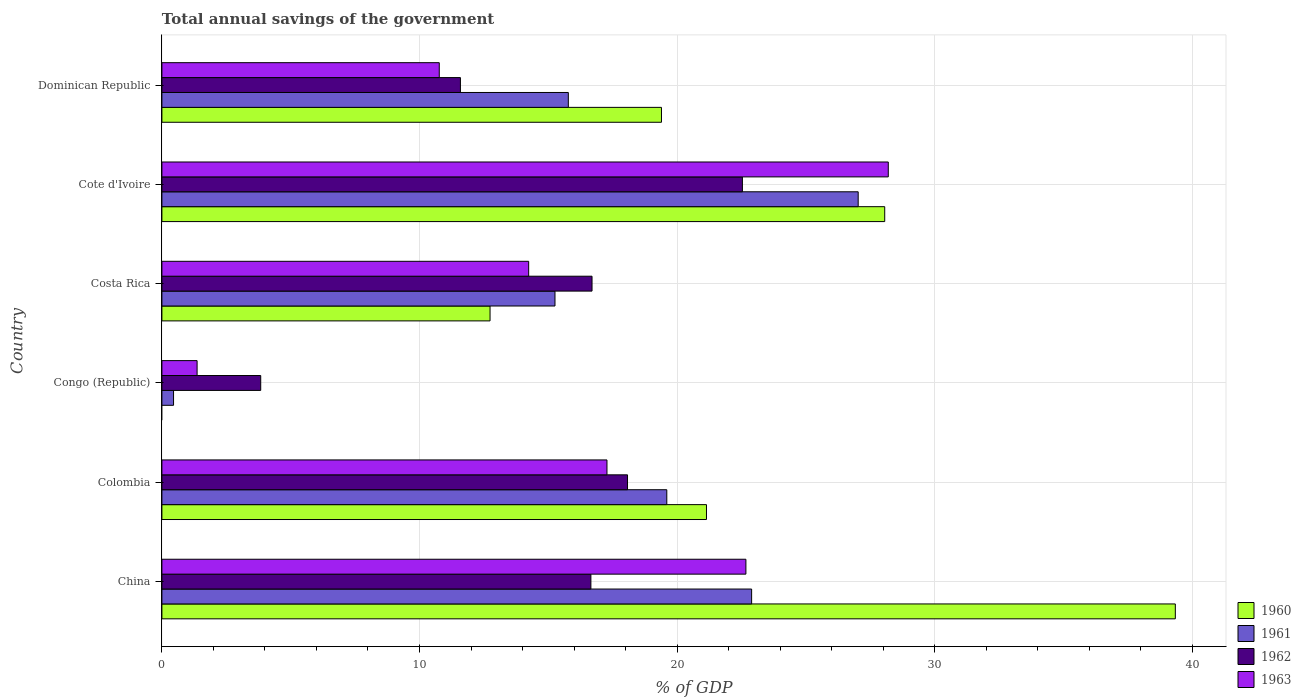How many groups of bars are there?
Offer a very short reply. 6. Are the number of bars per tick equal to the number of legend labels?
Your answer should be very brief. No. Are the number of bars on each tick of the Y-axis equal?
Your answer should be compact. No. What is the total annual savings of the government in 1961 in Congo (Republic)?
Provide a short and direct response. 0.45. Across all countries, what is the maximum total annual savings of the government in 1962?
Make the answer very short. 22.54. Across all countries, what is the minimum total annual savings of the government in 1963?
Your answer should be very brief. 1.37. In which country was the total annual savings of the government in 1962 maximum?
Keep it short and to the point. Cote d'Ivoire. What is the total total annual savings of the government in 1963 in the graph?
Your response must be concise. 94.52. What is the difference between the total annual savings of the government in 1963 in China and that in Cote d'Ivoire?
Offer a very short reply. -5.53. What is the difference between the total annual savings of the government in 1963 in Costa Rica and the total annual savings of the government in 1962 in Cote d'Ivoire?
Your answer should be very brief. -8.3. What is the average total annual savings of the government in 1963 per country?
Provide a short and direct response. 15.75. What is the difference between the total annual savings of the government in 1963 and total annual savings of the government in 1961 in China?
Keep it short and to the point. -0.22. In how many countries, is the total annual savings of the government in 1962 greater than 32 %?
Your response must be concise. 0. What is the ratio of the total annual savings of the government in 1963 in Congo (Republic) to that in Cote d'Ivoire?
Keep it short and to the point. 0.05. Is the total annual savings of the government in 1963 in China less than that in Dominican Republic?
Provide a succinct answer. No. What is the difference between the highest and the second highest total annual savings of the government in 1962?
Your answer should be compact. 4.46. What is the difference between the highest and the lowest total annual savings of the government in 1961?
Keep it short and to the point. 26.58. Are all the bars in the graph horizontal?
Keep it short and to the point. Yes. Does the graph contain any zero values?
Provide a short and direct response. Yes. Does the graph contain grids?
Your response must be concise. Yes. How are the legend labels stacked?
Provide a short and direct response. Vertical. What is the title of the graph?
Provide a succinct answer. Total annual savings of the government. Does "1969" appear as one of the legend labels in the graph?
Keep it short and to the point. No. What is the label or title of the X-axis?
Ensure brevity in your answer.  % of GDP. What is the label or title of the Y-axis?
Offer a terse response. Country. What is the % of GDP in 1960 in China?
Provide a short and direct response. 39.34. What is the % of GDP in 1961 in China?
Offer a very short reply. 22.89. What is the % of GDP in 1962 in China?
Keep it short and to the point. 16.65. What is the % of GDP of 1963 in China?
Provide a succinct answer. 22.67. What is the % of GDP of 1960 in Colombia?
Make the answer very short. 21.14. What is the % of GDP in 1961 in Colombia?
Keep it short and to the point. 19.6. What is the % of GDP of 1962 in Colombia?
Give a very brief answer. 18.08. What is the % of GDP in 1963 in Colombia?
Your response must be concise. 17.28. What is the % of GDP of 1960 in Congo (Republic)?
Your response must be concise. 0. What is the % of GDP of 1961 in Congo (Republic)?
Keep it short and to the point. 0.45. What is the % of GDP in 1962 in Congo (Republic)?
Your answer should be very brief. 3.84. What is the % of GDP in 1963 in Congo (Republic)?
Your response must be concise. 1.37. What is the % of GDP of 1960 in Costa Rica?
Offer a very short reply. 12.74. What is the % of GDP of 1961 in Costa Rica?
Your response must be concise. 15.26. What is the % of GDP in 1962 in Costa Rica?
Ensure brevity in your answer.  16.7. What is the % of GDP of 1963 in Costa Rica?
Your response must be concise. 14.24. What is the % of GDP in 1960 in Cote d'Ivoire?
Your answer should be compact. 28.06. What is the % of GDP in 1961 in Cote d'Ivoire?
Your answer should be very brief. 27.03. What is the % of GDP in 1962 in Cote d'Ivoire?
Your response must be concise. 22.54. What is the % of GDP of 1963 in Cote d'Ivoire?
Ensure brevity in your answer.  28.2. What is the % of GDP in 1960 in Dominican Republic?
Your response must be concise. 19.39. What is the % of GDP in 1961 in Dominican Republic?
Give a very brief answer. 15.78. What is the % of GDP in 1962 in Dominican Republic?
Provide a succinct answer. 11.59. What is the % of GDP of 1963 in Dominican Republic?
Provide a succinct answer. 10.77. Across all countries, what is the maximum % of GDP of 1960?
Your answer should be compact. 39.34. Across all countries, what is the maximum % of GDP of 1961?
Give a very brief answer. 27.03. Across all countries, what is the maximum % of GDP in 1962?
Offer a terse response. 22.54. Across all countries, what is the maximum % of GDP in 1963?
Offer a very short reply. 28.2. Across all countries, what is the minimum % of GDP of 1961?
Give a very brief answer. 0.45. Across all countries, what is the minimum % of GDP of 1962?
Provide a short and direct response. 3.84. Across all countries, what is the minimum % of GDP in 1963?
Offer a very short reply. 1.37. What is the total % of GDP of 1960 in the graph?
Give a very brief answer. 120.67. What is the total % of GDP of 1961 in the graph?
Offer a very short reply. 101.01. What is the total % of GDP of 1962 in the graph?
Keep it short and to the point. 89.39. What is the total % of GDP in 1963 in the graph?
Ensure brevity in your answer.  94.52. What is the difference between the % of GDP in 1960 in China and that in Colombia?
Your answer should be very brief. 18.2. What is the difference between the % of GDP of 1961 in China and that in Colombia?
Provide a short and direct response. 3.29. What is the difference between the % of GDP of 1962 in China and that in Colombia?
Your answer should be compact. -1.42. What is the difference between the % of GDP in 1963 in China and that in Colombia?
Offer a terse response. 5.39. What is the difference between the % of GDP in 1961 in China and that in Congo (Republic)?
Make the answer very short. 22.44. What is the difference between the % of GDP of 1962 in China and that in Congo (Republic)?
Provide a succinct answer. 12.82. What is the difference between the % of GDP in 1963 in China and that in Congo (Republic)?
Make the answer very short. 21.3. What is the difference between the % of GDP in 1960 in China and that in Costa Rica?
Ensure brevity in your answer.  26.6. What is the difference between the % of GDP of 1961 in China and that in Costa Rica?
Keep it short and to the point. 7.63. What is the difference between the % of GDP in 1962 in China and that in Costa Rica?
Your response must be concise. -0.04. What is the difference between the % of GDP in 1963 in China and that in Costa Rica?
Your answer should be very brief. 8.43. What is the difference between the % of GDP of 1960 in China and that in Cote d'Ivoire?
Make the answer very short. 11.28. What is the difference between the % of GDP in 1961 in China and that in Cote d'Ivoire?
Keep it short and to the point. -4.14. What is the difference between the % of GDP in 1962 in China and that in Cote d'Ivoire?
Make the answer very short. -5.88. What is the difference between the % of GDP of 1963 in China and that in Cote d'Ivoire?
Keep it short and to the point. -5.53. What is the difference between the % of GDP in 1960 in China and that in Dominican Republic?
Provide a short and direct response. 19.95. What is the difference between the % of GDP of 1961 in China and that in Dominican Republic?
Your response must be concise. 7.12. What is the difference between the % of GDP of 1962 in China and that in Dominican Republic?
Ensure brevity in your answer.  5.07. What is the difference between the % of GDP of 1963 in China and that in Dominican Republic?
Your response must be concise. 11.9. What is the difference between the % of GDP of 1961 in Colombia and that in Congo (Republic)?
Offer a very short reply. 19.15. What is the difference between the % of GDP of 1962 in Colombia and that in Congo (Republic)?
Give a very brief answer. 14.24. What is the difference between the % of GDP in 1963 in Colombia and that in Congo (Republic)?
Offer a very short reply. 15.91. What is the difference between the % of GDP in 1960 in Colombia and that in Costa Rica?
Provide a short and direct response. 8.4. What is the difference between the % of GDP of 1961 in Colombia and that in Costa Rica?
Keep it short and to the point. 4.34. What is the difference between the % of GDP in 1962 in Colombia and that in Costa Rica?
Offer a terse response. 1.38. What is the difference between the % of GDP of 1963 in Colombia and that in Costa Rica?
Ensure brevity in your answer.  3.04. What is the difference between the % of GDP of 1960 in Colombia and that in Cote d'Ivoire?
Keep it short and to the point. -6.92. What is the difference between the % of GDP in 1961 in Colombia and that in Cote d'Ivoire?
Make the answer very short. -7.43. What is the difference between the % of GDP in 1962 in Colombia and that in Cote d'Ivoire?
Make the answer very short. -4.46. What is the difference between the % of GDP of 1963 in Colombia and that in Cote d'Ivoire?
Offer a terse response. -10.92. What is the difference between the % of GDP in 1960 in Colombia and that in Dominican Republic?
Offer a very short reply. 1.75. What is the difference between the % of GDP in 1961 in Colombia and that in Dominican Republic?
Your answer should be very brief. 3.82. What is the difference between the % of GDP in 1962 in Colombia and that in Dominican Republic?
Your response must be concise. 6.49. What is the difference between the % of GDP in 1963 in Colombia and that in Dominican Republic?
Provide a succinct answer. 6.51. What is the difference between the % of GDP of 1961 in Congo (Republic) and that in Costa Rica?
Ensure brevity in your answer.  -14.81. What is the difference between the % of GDP of 1962 in Congo (Republic) and that in Costa Rica?
Keep it short and to the point. -12.86. What is the difference between the % of GDP of 1963 in Congo (Republic) and that in Costa Rica?
Provide a short and direct response. -12.87. What is the difference between the % of GDP in 1961 in Congo (Republic) and that in Cote d'Ivoire?
Your response must be concise. -26.58. What is the difference between the % of GDP in 1962 in Congo (Republic) and that in Cote d'Ivoire?
Your response must be concise. -18.7. What is the difference between the % of GDP in 1963 in Congo (Republic) and that in Cote d'Ivoire?
Provide a short and direct response. -26.83. What is the difference between the % of GDP of 1961 in Congo (Republic) and that in Dominican Republic?
Make the answer very short. -15.33. What is the difference between the % of GDP in 1962 in Congo (Republic) and that in Dominican Republic?
Give a very brief answer. -7.75. What is the difference between the % of GDP of 1963 in Congo (Republic) and that in Dominican Republic?
Give a very brief answer. -9.4. What is the difference between the % of GDP in 1960 in Costa Rica and that in Cote d'Ivoire?
Your response must be concise. -15.32. What is the difference between the % of GDP of 1961 in Costa Rica and that in Cote d'Ivoire?
Give a very brief answer. -11.77. What is the difference between the % of GDP in 1962 in Costa Rica and that in Cote d'Ivoire?
Provide a succinct answer. -5.84. What is the difference between the % of GDP of 1963 in Costa Rica and that in Cote d'Ivoire?
Provide a succinct answer. -13.96. What is the difference between the % of GDP in 1960 in Costa Rica and that in Dominican Republic?
Your response must be concise. -6.65. What is the difference between the % of GDP in 1961 in Costa Rica and that in Dominican Republic?
Your response must be concise. -0.52. What is the difference between the % of GDP of 1962 in Costa Rica and that in Dominican Republic?
Your response must be concise. 5.11. What is the difference between the % of GDP in 1963 in Costa Rica and that in Dominican Republic?
Keep it short and to the point. 3.47. What is the difference between the % of GDP of 1960 in Cote d'Ivoire and that in Dominican Republic?
Your response must be concise. 8.67. What is the difference between the % of GDP in 1961 in Cote d'Ivoire and that in Dominican Republic?
Give a very brief answer. 11.25. What is the difference between the % of GDP of 1962 in Cote d'Ivoire and that in Dominican Republic?
Your answer should be compact. 10.95. What is the difference between the % of GDP in 1963 in Cote d'Ivoire and that in Dominican Republic?
Your answer should be compact. 17.43. What is the difference between the % of GDP in 1960 in China and the % of GDP in 1961 in Colombia?
Offer a terse response. 19.74. What is the difference between the % of GDP of 1960 in China and the % of GDP of 1962 in Colombia?
Ensure brevity in your answer.  21.27. What is the difference between the % of GDP of 1960 in China and the % of GDP of 1963 in Colombia?
Keep it short and to the point. 22.06. What is the difference between the % of GDP in 1961 in China and the % of GDP in 1962 in Colombia?
Keep it short and to the point. 4.82. What is the difference between the % of GDP of 1961 in China and the % of GDP of 1963 in Colombia?
Your response must be concise. 5.62. What is the difference between the % of GDP of 1962 in China and the % of GDP of 1963 in Colombia?
Give a very brief answer. -0.62. What is the difference between the % of GDP in 1960 in China and the % of GDP in 1961 in Congo (Republic)?
Provide a succinct answer. 38.89. What is the difference between the % of GDP in 1960 in China and the % of GDP in 1962 in Congo (Republic)?
Provide a succinct answer. 35.5. What is the difference between the % of GDP in 1960 in China and the % of GDP in 1963 in Congo (Republic)?
Ensure brevity in your answer.  37.97. What is the difference between the % of GDP in 1961 in China and the % of GDP in 1962 in Congo (Republic)?
Offer a very short reply. 19.06. What is the difference between the % of GDP in 1961 in China and the % of GDP in 1963 in Congo (Republic)?
Make the answer very short. 21.53. What is the difference between the % of GDP of 1962 in China and the % of GDP of 1963 in Congo (Republic)?
Your answer should be compact. 15.29. What is the difference between the % of GDP in 1960 in China and the % of GDP in 1961 in Costa Rica?
Offer a very short reply. 24.08. What is the difference between the % of GDP of 1960 in China and the % of GDP of 1962 in Costa Rica?
Provide a short and direct response. 22.64. What is the difference between the % of GDP in 1960 in China and the % of GDP in 1963 in Costa Rica?
Provide a short and direct response. 25.1. What is the difference between the % of GDP in 1961 in China and the % of GDP in 1962 in Costa Rica?
Ensure brevity in your answer.  6.2. What is the difference between the % of GDP of 1961 in China and the % of GDP of 1963 in Costa Rica?
Provide a succinct answer. 8.66. What is the difference between the % of GDP of 1962 in China and the % of GDP of 1963 in Costa Rica?
Make the answer very short. 2.42. What is the difference between the % of GDP of 1960 in China and the % of GDP of 1961 in Cote d'Ivoire?
Offer a terse response. 12.31. What is the difference between the % of GDP of 1960 in China and the % of GDP of 1962 in Cote d'Ivoire?
Ensure brevity in your answer.  16.81. What is the difference between the % of GDP in 1960 in China and the % of GDP in 1963 in Cote d'Ivoire?
Keep it short and to the point. 11.14. What is the difference between the % of GDP in 1961 in China and the % of GDP in 1962 in Cote d'Ivoire?
Keep it short and to the point. 0.36. What is the difference between the % of GDP of 1961 in China and the % of GDP of 1963 in Cote d'Ivoire?
Offer a terse response. -5.3. What is the difference between the % of GDP in 1962 in China and the % of GDP in 1963 in Cote d'Ivoire?
Provide a succinct answer. -11.54. What is the difference between the % of GDP of 1960 in China and the % of GDP of 1961 in Dominican Republic?
Provide a succinct answer. 23.56. What is the difference between the % of GDP in 1960 in China and the % of GDP in 1962 in Dominican Republic?
Your answer should be very brief. 27.75. What is the difference between the % of GDP of 1960 in China and the % of GDP of 1963 in Dominican Republic?
Ensure brevity in your answer.  28.57. What is the difference between the % of GDP in 1961 in China and the % of GDP in 1962 in Dominican Republic?
Provide a succinct answer. 11.3. What is the difference between the % of GDP of 1961 in China and the % of GDP of 1963 in Dominican Republic?
Provide a short and direct response. 12.13. What is the difference between the % of GDP of 1962 in China and the % of GDP of 1963 in Dominican Republic?
Offer a very short reply. 5.89. What is the difference between the % of GDP of 1960 in Colombia and the % of GDP of 1961 in Congo (Republic)?
Make the answer very short. 20.69. What is the difference between the % of GDP of 1960 in Colombia and the % of GDP of 1962 in Congo (Republic)?
Your answer should be compact. 17.3. What is the difference between the % of GDP in 1960 in Colombia and the % of GDP in 1963 in Congo (Republic)?
Provide a succinct answer. 19.77. What is the difference between the % of GDP in 1961 in Colombia and the % of GDP in 1962 in Congo (Republic)?
Make the answer very short. 15.76. What is the difference between the % of GDP in 1961 in Colombia and the % of GDP in 1963 in Congo (Republic)?
Ensure brevity in your answer.  18.23. What is the difference between the % of GDP of 1962 in Colombia and the % of GDP of 1963 in Congo (Republic)?
Give a very brief answer. 16.71. What is the difference between the % of GDP in 1960 in Colombia and the % of GDP in 1961 in Costa Rica?
Offer a very short reply. 5.88. What is the difference between the % of GDP in 1960 in Colombia and the % of GDP in 1962 in Costa Rica?
Offer a terse response. 4.44. What is the difference between the % of GDP of 1960 in Colombia and the % of GDP of 1963 in Costa Rica?
Ensure brevity in your answer.  6.9. What is the difference between the % of GDP in 1961 in Colombia and the % of GDP in 1962 in Costa Rica?
Keep it short and to the point. 2.9. What is the difference between the % of GDP in 1961 in Colombia and the % of GDP in 1963 in Costa Rica?
Provide a succinct answer. 5.36. What is the difference between the % of GDP in 1962 in Colombia and the % of GDP in 1963 in Costa Rica?
Give a very brief answer. 3.84. What is the difference between the % of GDP of 1960 in Colombia and the % of GDP of 1961 in Cote d'Ivoire?
Provide a short and direct response. -5.89. What is the difference between the % of GDP in 1960 in Colombia and the % of GDP in 1962 in Cote d'Ivoire?
Your answer should be very brief. -1.39. What is the difference between the % of GDP in 1960 in Colombia and the % of GDP in 1963 in Cote d'Ivoire?
Offer a very short reply. -7.06. What is the difference between the % of GDP in 1961 in Colombia and the % of GDP in 1962 in Cote d'Ivoire?
Provide a succinct answer. -2.94. What is the difference between the % of GDP of 1961 in Colombia and the % of GDP of 1963 in Cote d'Ivoire?
Make the answer very short. -8.6. What is the difference between the % of GDP of 1962 in Colombia and the % of GDP of 1963 in Cote d'Ivoire?
Offer a terse response. -10.12. What is the difference between the % of GDP of 1960 in Colombia and the % of GDP of 1961 in Dominican Republic?
Your response must be concise. 5.36. What is the difference between the % of GDP in 1960 in Colombia and the % of GDP in 1962 in Dominican Republic?
Give a very brief answer. 9.55. What is the difference between the % of GDP in 1960 in Colombia and the % of GDP in 1963 in Dominican Republic?
Your response must be concise. 10.37. What is the difference between the % of GDP in 1961 in Colombia and the % of GDP in 1962 in Dominican Republic?
Provide a succinct answer. 8.01. What is the difference between the % of GDP of 1961 in Colombia and the % of GDP of 1963 in Dominican Republic?
Offer a very short reply. 8.83. What is the difference between the % of GDP of 1962 in Colombia and the % of GDP of 1963 in Dominican Republic?
Provide a short and direct response. 7.31. What is the difference between the % of GDP in 1961 in Congo (Republic) and the % of GDP in 1962 in Costa Rica?
Ensure brevity in your answer.  -16.25. What is the difference between the % of GDP of 1961 in Congo (Republic) and the % of GDP of 1963 in Costa Rica?
Provide a succinct answer. -13.79. What is the difference between the % of GDP of 1962 in Congo (Republic) and the % of GDP of 1963 in Costa Rica?
Your response must be concise. -10.4. What is the difference between the % of GDP in 1961 in Congo (Republic) and the % of GDP in 1962 in Cote d'Ivoire?
Offer a very short reply. -22.08. What is the difference between the % of GDP in 1961 in Congo (Republic) and the % of GDP in 1963 in Cote d'Ivoire?
Give a very brief answer. -27.75. What is the difference between the % of GDP in 1962 in Congo (Republic) and the % of GDP in 1963 in Cote d'Ivoire?
Your response must be concise. -24.36. What is the difference between the % of GDP in 1961 in Congo (Republic) and the % of GDP in 1962 in Dominican Republic?
Offer a terse response. -11.14. What is the difference between the % of GDP in 1961 in Congo (Republic) and the % of GDP in 1963 in Dominican Republic?
Offer a very short reply. -10.32. What is the difference between the % of GDP of 1962 in Congo (Republic) and the % of GDP of 1963 in Dominican Republic?
Give a very brief answer. -6.93. What is the difference between the % of GDP of 1960 in Costa Rica and the % of GDP of 1961 in Cote d'Ivoire?
Your answer should be very brief. -14.29. What is the difference between the % of GDP of 1960 in Costa Rica and the % of GDP of 1962 in Cote d'Ivoire?
Provide a succinct answer. -9.8. What is the difference between the % of GDP in 1960 in Costa Rica and the % of GDP in 1963 in Cote d'Ivoire?
Provide a succinct answer. -15.46. What is the difference between the % of GDP in 1961 in Costa Rica and the % of GDP in 1962 in Cote d'Ivoire?
Your answer should be compact. -7.28. What is the difference between the % of GDP in 1961 in Costa Rica and the % of GDP in 1963 in Cote d'Ivoire?
Provide a succinct answer. -12.94. What is the difference between the % of GDP of 1962 in Costa Rica and the % of GDP of 1963 in Cote d'Ivoire?
Ensure brevity in your answer.  -11.5. What is the difference between the % of GDP of 1960 in Costa Rica and the % of GDP of 1961 in Dominican Republic?
Provide a short and direct response. -3.04. What is the difference between the % of GDP in 1960 in Costa Rica and the % of GDP in 1962 in Dominican Republic?
Offer a very short reply. 1.15. What is the difference between the % of GDP of 1960 in Costa Rica and the % of GDP of 1963 in Dominican Republic?
Your answer should be compact. 1.97. What is the difference between the % of GDP of 1961 in Costa Rica and the % of GDP of 1962 in Dominican Republic?
Offer a very short reply. 3.67. What is the difference between the % of GDP of 1961 in Costa Rica and the % of GDP of 1963 in Dominican Republic?
Provide a short and direct response. 4.49. What is the difference between the % of GDP in 1962 in Costa Rica and the % of GDP in 1963 in Dominican Republic?
Provide a short and direct response. 5.93. What is the difference between the % of GDP of 1960 in Cote d'Ivoire and the % of GDP of 1961 in Dominican Republic?
Your answer should be very brief. 12.28. What is the difference between the % of GDP of 1960 in Cote d'Ivoire and the % of GDP of 1962 in Dominican Republic?
Make the answer very short. 16.47. What is the difference between the % of GDP of 1960 in Cote d'Ivoire and the % of GDP of 1963 in Dominican Republic?
Your answer should be compact. 17.29. What is the difference between the % of GDP of 1961 in Cote d'Ivoire and the % of GDP of 1962 in Dominican Republic?
Your response must be concise. 15.44. What is the difference between the % of GDP of 1961 in Cote d'Ivoire and the % of GDP of 1963 in Dominican Republic?
Give a very brief answer. 16.26. What is the difference between the % of GDP in 1962 in Cote d'Ivoire and the % of GDP in 1963 in Dominican Republic?
Ensure brevity in your answer.  11.77. What is the average % of GDP in 1960 per country?
Keep it short and to the point. 20.11. What is the average % of GDP in 1961 per country?
Offer a terse response. 16.84. What is the average % of GDP of 1962 per country?
Give a very brief answer. 14.9. What is the average % of GDP in 1963 per country?
Your response must be concise. 15.75. What is the difference between the % of GDP of 1960 and % of GDP of 1961 in China?
Your response must be concise. 16.45. What is the difference between the % of GDP in 1960 and % of GDP in 1962 in China?
Provide a succinct answer. 22.69. What is the difference between the % of GDP in 1960 and % of GDP in 1963 in China?
Make the answer very short. 16.67. What is the difference between the % of GDP of 1961 and % of GDP of 1962 in China?
Your answer should be compact. 6.24. What is the difference between the % of GDP in 1961 and % of GDP in 1963 in China?
Your response must be concise. 0.22. What is the difference between the % of GDP of 1962 and % of GDP of 1963 in China?
Your response must be concise. -6.02. What is the difference between the % of GDP of 1960 and % of GDP of 1961 in Colombia?
Offer a terse response. 1.54. What is the difference between the % of GDP in 1960 and % of GDP in 1962 in Colombia?
Your answer should be very brief. 3.07. What is the difference between the % of GDP of 1960 and % of GDP of 1963 in Colombia?
Provide a succinct answer. 3.86. What is the difference between the % of GDP of 1961 and % of GDP of 1962 in Colombia?
Provide a short and direct response. 1.53. What is the difference between the % of GDP of 1961 and % of GDP of 1963 in Colombia?
Your answer should be compact. 2.32. What is the difference between the % of GDP of 1962 and % of GDP of 1963 in Colombia?
Provide a short and direct response. 0.8. What is the difference between the % of GDP in 1961 and % of GDP in 1962 in Congo (Republic)?
Your answer should be compact. -3.38. What is the difference between the % of GDP in 1961 and % of GDP in 1963 in Congo (Republic)?
Provide a succinct answer. -0.91. What is the difference between the % of GDP of 1962 and % of GDP of 1963 in Congo (Republic)?
Your response must be concise. 2.47. What is the difference between the % of GDP of 1960 and % of GDP of 1961 in Costa Rica?
Offer a terse response. -2.52. What is the difference between the % of GDP in 1960 and % of GDP in 1962 in Costa Rica?
Make the answer very short. -3.96. What is the difference between the % of GDP in 1960 and % of GDP in 1963 in Costa Rica?
Your response must be concise. -1.5. What is the difference between the % of GDP in 1961 and % of GDP in 1962 in Costa Rica?
Make the answer very short. -1.44. What is the difference between the % of GDP in 1961 and % of GDP in 1963 in Costa Rica?
Make the answer very short. 1.02. What is the difference between the % of GDP of 1962 and % of GDP of 1963 in Costa Rica?
Keep it short and to the point. 2.46. What is the difference between the % of GDP of 1960 and % of GDP of 1962 in Cote d'Ivoire?
Your answer should be very brief. 5.52. What is the difference between the % of GDP in 1960 and % of GDP in 1963 in Cote d'Ivoire?
Make the answer very short. -0.14. What is the difference between the % of GDP in 1961 and % of GDP in 1962 in Cote d'Ivoire?
Keep it short and to the point. 4.49. What is the difference between the % of GDP in 1961 and % of GDP in 1963 in Cote d'Ivoire?
Provide a short and direct response. -1.17. What is the difference between the % of GDP of 1962 and % of GDP of 1963 in Cote d'Ivoire?
Offer a very short reply. -5.66. What is the difference between the % of GDP of 1960 and % of GDP of 1961 in Dominican Republic?
Your response must be concise. 3.62. What is the difference between the % of GDP in 1960 and % of GDP in 1962 in Dominican Republic?
Give a very brief answer. 7.8. What is the difference between the % of GDP of 1960 and % of GDP of 1963 in Dominican Republic?
Keep it short and to the point. 8.63. What is the difference between the % of GDP in 1961 and % of GDP in 1962 in Dominican Republic?
Your response must be concise. 4.19. What is the difference between the % of GDP of 1961 and % of GDP of 1963 in Dominican Republic?
Keep it short and to the point. 5.01. What is the difference between the % of GDP in 1962 and % of GDP in 1963 in Dominican Republic?
Give a very brief answer. 0.82. What is the ratio of the % of GDP of 1960 in China to that in Colombia?
Your answer should be compact. 1.86. What is the ratio of the % of GDP in 1961 in China to that in Colombia?
Ensure brevity in your answer.  1.17. What is the ratio of the % of GDP in 1962 in China to that in Colombia?
Provide a short and direct response. 0.92. What is the ratio of the % of GDP of 1963 in China to that in Colombia?
Your response must be concise. 1.31. What is the ratio of the % of GDP in 1961 in China to that in Congo (Republic)?
Keep it short and to the point. 50.67. What is the ratio of the % of GDP in 1962 in China to that in Congo (Republic)?
Provide a succinct answer. 4.34. What is the ratio of the % of GDP of 1963 in China to that in Congo (Republic)?
Provide a succinct answer. 16.59. What is the ratio of the % of GDP of 1960 in China to that in Costa Rica?
Your answer should be compact. 3.09. What is the ratio of the % of GDP of 1961 in China to that in Costa Rica?
Your response must be concise. 1.5. What is the ratio of the % of GDP of 1962 in China to that in Costa Rica?
Ensure brevity in your answer.  1. What is the ratio of the % of GDP of 1963 in China to that in Costa Rica?
Offer a very short reply. 1.59. What is the ratio of the % of GDP in 1960 in China to that in Cote d'Ivoire?
Provide a short and direct response. 1.4. What is the ratio of the % of GDP in 1961 in China to that in Cote d'Ivoire?
Offer a terse response. 0.85. What is the ratio of the % of GDP of 1962 in China to that in Cote d'Ivoire?
Make the answer very short. 0.74. What is the ratio of the % of GDP in 1963 in China to that in Cote d'Ivoire?
Offer a terse response. 0.8. What is the ratio of the % of GDP of 1960 in China to that in Dominican Republic?
Provide a short and direct response. 2.03. What is the ratio of the % of GDP of 1961 in China to that in Dominican Republic?
Provide a succinct answer. 1.45. What is the ratio of the % of GDP in 1962 in China to that in Dominican Republic?
Your answer should be compact. 1.44. What is the ratio of the % of GDP of 1963 in China to that in Dominican Republic?
Offer a very short reply. 2.11. What is the ratio of the % of GDP in 1961 in Colombia to that in Congo (Republic)?
Keep it short and to the point. 43.38. What is the ratio of the % of GDP of 1962 in Colombia to that in Congo (Republic)?
Offer a very short reply. 4.71. What is the ratio of the % of GDP of 1963 in Colombia to that in Congo (Republic)?
Offer a terse response. 12.64. What is the ratio of the % of GDP in 1960 in Colombia to that in Costa Rica?
Provide a succinct answer. 1.66. What is the ratio of the % of GDP in 1961 in Colombia to that in Costa Rica?
Your response must be concise. 1.28. What is the ratio of the % of GDP in 1962 in Colombia to that in Costa Rica?
Give a very brief answer. 1.08. What is the ratio of the % of GDP of 1963 in Colombia to that in Costa Rica?
Ensure brevity in your answer.  1.21. What is the ratio of the % of GDP in 1960 in Colombia to that in Cote d'Ivoire?
Make the answer very short. 0.75. What is the ratio of the % of GDP of 1961 in Colombia to that in Cote d'Ivoire?
Offer a terse response. 0.73. What is the ratio of the % of GDP of 1962 in Colombia to that in Cote d'Ivoire?
Provide a succinct answer. 0.8. What is the ratio of the % of GDP of 1963 in Colombia to that in Cote d'Ivoire?
Make the answer very short. 0.61. What is the ratio of the % of GDP of 1960 in Colombia to that in Dominican Republic?
Your answer should be very brief. 1.09. What is the ratio of the % of GDP of 1961 in Colombia to that in Dominican Republic?
Offer a terse response. 1.24. What is the ratio of the % of GDP in 1962 in Colombia to that in Dominican Republic?
Keep it short and to the point. 1.56. What is the ratio of the % of GDP of 1963 in Colombia to that in Dominican Republic?
Your answer should be compact. 1.6. What is the ratio of the % of GDP in 1961 in Congo (Republic) to that in Costa Rica?
Your answer should be compact. 0.03. What is the ratio of the % of GDP of 1962 in Congo (Republic) to that in Costa Rica?
Offer a terse response. 0.23. What is the ratio of the % of GDP of 1963 in Congo (Republic) to that in Costa Rica?
Make the answer very short. 0.1. What is the ratio of the % of GDP of 1961 in Congo (Republic) to that in Cote d'Ivoire?
Ensure brevity in your answer.  0.02. What is the ratio of the % of GDP in 1962 in Congo (Republic) to that in Cote d'Ivoire?
Your response must be concise. 0.17. What is the ratio of the % of GDP in 1963 in Congo (Republic) to that in Cote d'Ivoire?
Your answer should be compact. 0.05. What is the ratio of the % of GDP of 1961 in Congo (Republic) to that in Dominican Republic?
Make the answer very short. 0.03. What is the ratio of the % of GDP of 1962 in Congo (Republic) to that in Dominican Republic?
Your response must be concise. 0.33. What is the ratio of the % of GDP of 1963 in Congo (Republic) to that in Dominican Republic?
Provide a short and direct response. 0.13. What is the ratio of the % of GDP of 1960 in Costa Rica to that in Cote d'Ivoire?
Offer a terse response. 0.45. What is the ratio of the % of GDP in 1961 in Costa Rica to that in Cote d'Ivoire?
Make the answer very short. 0.56. What is the ratio of the % of GDP in 1962 in Costa Rica to that in Cote d'Ivoire?
Ensure brevity in your answer.  0.74. What is the ratio of the % of GDP of 1963 in Costa Rica to that in Cote d'Ivoire?
Offer a terse response. 0.5. What is the ratio of the % of GDP in 1960 in Costa Rica to that in Dominican Republic?
Your answer should be compact. 0.66. What is the ratio of the % of GDP of 1961 in Costa Rica to that in Dominican Republic?
Provide a short and direct response. 0.97. What is the ratio of the % of GDP of 1962 in Costa Rica to that in Dominican Republic?
Provide a short and direct response. 1.44. What is the ratio of the % of GDP in 1963 in Costa Rica to that in Dominican Republic?
Your answer should be compact. 1.32. What is the ratio of the % of GDP in 1960 in Cote d'Ivoire to that in Dominican Republic?
Your response must be concise. 1.45. What is the ratio of the % of GDP of 1961 in Cote d'Ivoire to that in Dominican Republic?
Offer a terse response. 1.71. What is the ratio of the % of GDP of 1962 in Cote d'Ivoire to that in Dominican Republic?
Ensure brevity in your answer.  1.94. What is the ratio of the % of GDP in 1963 in Cote d'Ivoire to that in Dominican Republic?
Your answer should be very brief. 2.62. What is the difference between the highest and the second highest % of GDP of 1960?
Make the answer very short. 11.28. What is the difference between the highest and the second highest % of GDP in 1961?
Provide a succinct answer. 4.14. What is the difference between the highest and the second highest % of GDP of 1962?
Provide a succinct answer. 4.46. What is the difference between the highest and the second highest % of GDP in 1963?
Keep it short and to the point. 5.53. What is the difference between the highest and the lowest % of GDP of 1960?
Offer a terse response. 39.34. What is the difference between the highest and the lowest % of GDP of 1961?
Your response must be concise. 26.58. What is the difference between the highest and the lowest % of GDP of 1962?
Your answer should be very brief. 18.7. What is the difference between the highest and the lowest % of GDP of 1963?
Provide a short and direct response. 26.83. 